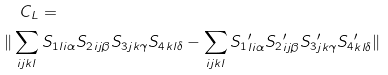<formula> <loc_0><loc_0><loc_500><loc_500>& \quad C _ { L } = \\ & \| \sum _ { i j k l } { S _ { 1 } } _ { l i \alpha } { S _ { 2 } } _ { i j \beta } { S _ { 3 } } _ { j k \gamma } { S _ { 4 } } _ { k l \delta } - \sum _ { i j k l } { S _ { 1 } } ^ { \prime } _ { l i \alpha } { S _ { 2 } } ^ { \prime } _ { i j \beta } { S _ { 3 } } ^ { \prime } _ { j k \gamma } { S _ { 4 } } ^ { \prime } _ { k l \delta } \|</formula> 